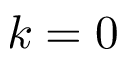<formula> <loc_0><loc_0><loc_500><loc_500>k = 0</formula> 